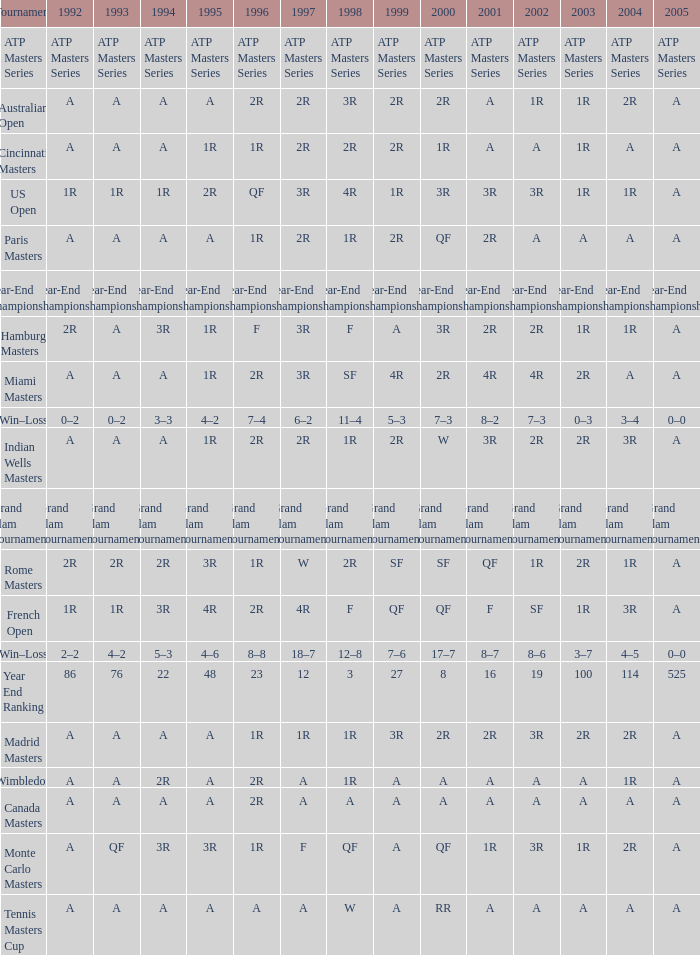Can you give me this table as a dict? {'header': ['Tournament', '1992', '1993', '1994', '1995', '1996', '1997', '1998', '1999', '2000', '2001', '2002', '2003', '2004', '2005'], 'rows': [['ATP Masters Series', 'ATP Masters Series', 'ATP Masters Series', 'ATP Masters Series', 'ATP Masters Series', 'ATP Masters Series', 'ATP Masters Series', 'ATP Masters Series', 'ATP Masters Series', 'ATP Masters Series', 'ATP Masters Series', 'ATP Masters Series', 'ATP Masters Series', 'ATP Masters Series', 'ATP Masters Series'], ['Australian Open', 'A', 'A', 'A', 'A', '2R', '2R', '3R', '2R', '2R', 'A', '1R', '1R', '2R', 'A'], ['Cincinnati Masters', 'A', 'A', 'A', '1R', '1R', '2R', '2R', '2R', '1R', 'A', 'A', '1R', 'A', 'A'], ['US Open', '1R', '1R', '1R', '2R', 'QF', '3R', '4R', '1R', '3R', '3R', '3R', '1R', '1R', 'A'], ['Paris Masters', 'A', 'A', 'A', 'A', '1R', '2R', '1R', '2R', 'QF', '2R', 'A', 'A', 'A', 'A'], ['Year-End Championship', 'Year-End Championship', 'Year-End Championship', 'Year-End Championship', 'Year-End Championship', 'Year-End Championship', 'Year-End Championship', 'Year-End Championship', 'Year-End Championship', 'Year-End Championship', 'Year-End Championship', 'Year-End Championship', 'Year-End Championship', 'Year-End Championship', 'Year-End Championship'], ['Hamburg Masters', '2R', 'A', '3R', '1R', 'F', '3R', 'F', 'A', '3R', '2R', '2R', '1R', '1R', 'A'], ['Miami Masters', 'A', 'A', 'A', '1R', '2R', '3R', 'SF', '4R', '2R', '4R', '4R', '2R', 'A', 'A'], ['Win–Loss', '0–2', '0–2', '3–3', '4–2', '7–4', '6–2', '11–4', '5–3', '7–3', '8–2', '7–3', '0–3', '3–4', '0–0'], ['Indian Wells Masters', 'A', 'A', 'A', '1R', '2R', '2R', '1R', '2R', 'W', '3R', '2R', '2R', '3R', 'A'], ['Grand Slam Tournaments', 'Grand Slam Tournaments', 'Grand Slam Tournaments', 'Grand Slam Tournaments', 'Grand Slam Tournaments', 'Grand Slam Tournaments', 'Grand Slam Tournaments', 'Grand Slam Tournaments', 'Grand Slam Tournaments', 'Grand Slam Tournaments', 'Grand Slam Tournaments', 'Grand Slam Tournaments', 'Grand Slam Tournaments', 'Grand Slam Tournaments', 'Grand Slam Tournaments'], ['Rome Masters', '2R', '2R', '2R', '3R', '1R', 'W', '2R', 'SF', 'SF', 'QF', '1R', '2R', '1R', 'A'], ['French Open', '1R', '1R', '3R', '4R', '2R', '4R', 'F', 'QF', 'QF', 'F', 'SF', '1R', '3R', 'A'], ['Win–Loss', '2–2', '4–2', '5–3', '4–6', '8–8', '18–7', '12–8', '7–6', '17–7', '8–7', '8–6', '3–7', '4–5', '0–0'], ['Year End Ranking', '86', '76', '22', '48', '23', '12', '3', '27', '8', '16', '19', '100', '114', '525'], ['Madrid Masters', 'A', 'A', 'A', 'A', '1R', '1R', '1R', '3R', '2R', '2R', '3R', '2R', '2R', 'A'], ['Wimbledon', 'A', 'A', '2R', 'A', '2R', 'A', '1R', 'A', 'A', 'A', 'A', 'A', '1R', 'A'], ['Canada Masters', 'A', 'A', 'A', 'A', '2R', 'A', 'A', 'A', 'A', 'A', 'A', 'A', 'A', 'A'], ['Monte Carlo Masters', 'A', 'QF', '3R', '3R', '1R', 'F', 'QF', 'A', 'QF', '1R', '3R', '1R', '2R', 'A'], ['Tennis Masters Cup', 'A', 'A', 'A', 'A', 'A', 'A', 'W', 'A', 'RR', 'A', 'A', 'A', 'A', 'A']]} What is 2005, when 1998 is "F", and when 2002 is "2R"? A. 